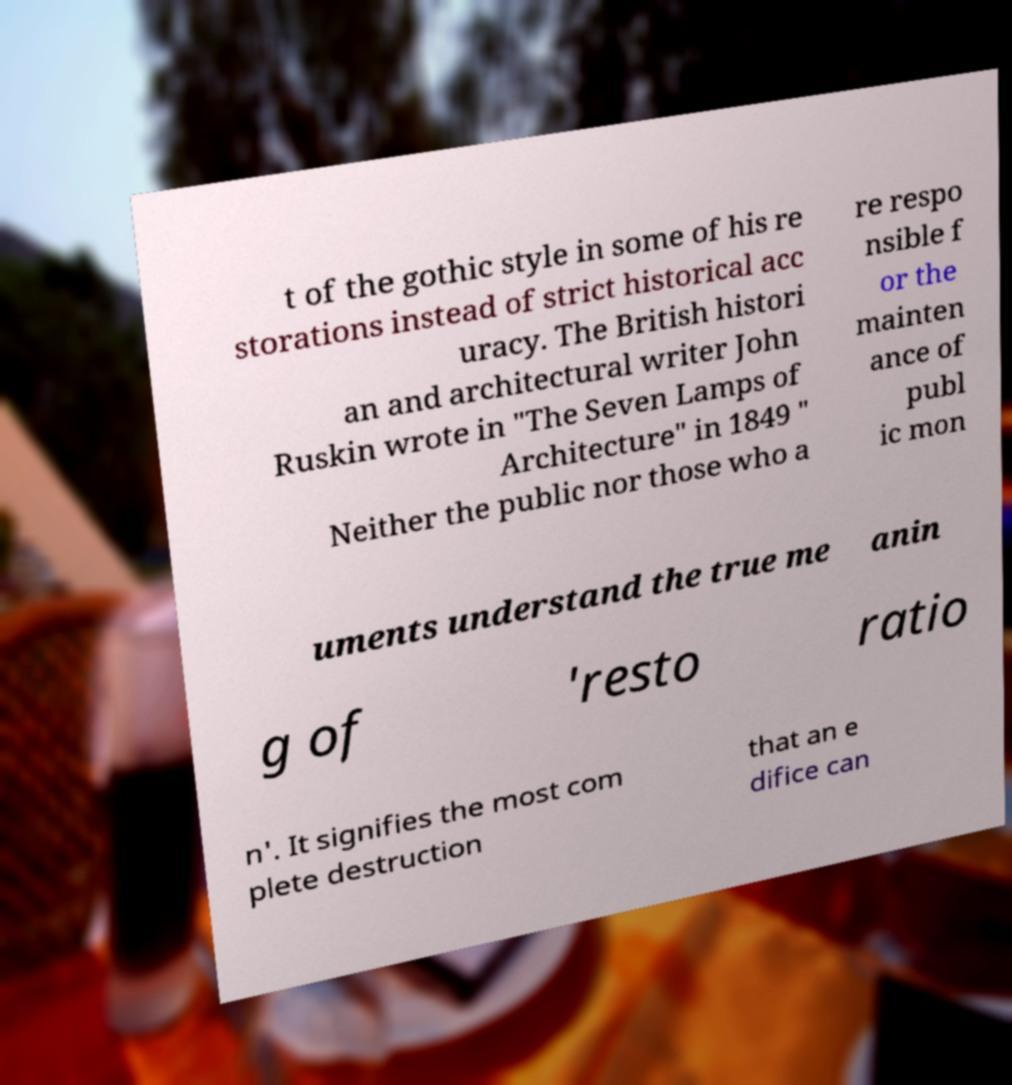I need the written content from this picture converted into text. Can you do that? t of the gothic style in some of his re storations instead of strict historical acc uracy. The British histori an and architectural writer John Ruskin wrote in "The Seven Lamps of Architecture" in 1849 " Neither the public nor those who a re respo nsible f or the mainten ance of publ ic mon uments understand the true me anin g of 'resto ratio n'. It signifies the most com plete destruction that an e difice can 